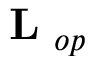<formula> <loc_0><loc_0><loc_500><loc_500>L _ { o p }</formula> 